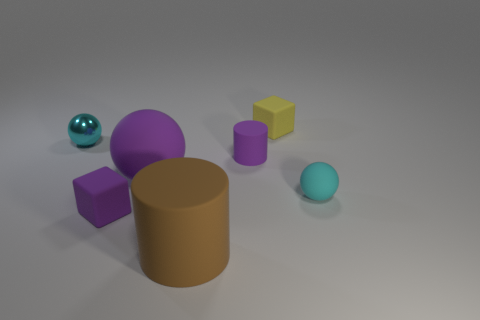Add 1 large matte balls. How many objects exist? 8 Subtract all cubes. How many objects are left? 5 Add 7 tiny cubes. How many tiny cubes exist? 9 Subtract 0 blue spheres. How many objects are left? 7 Subtract all large blue spheres. Subtract all small cubes. How many objects are left? 5 Add 5 tiny purple matte cylinders. How many tiny purple matte cylinders are left? 6 